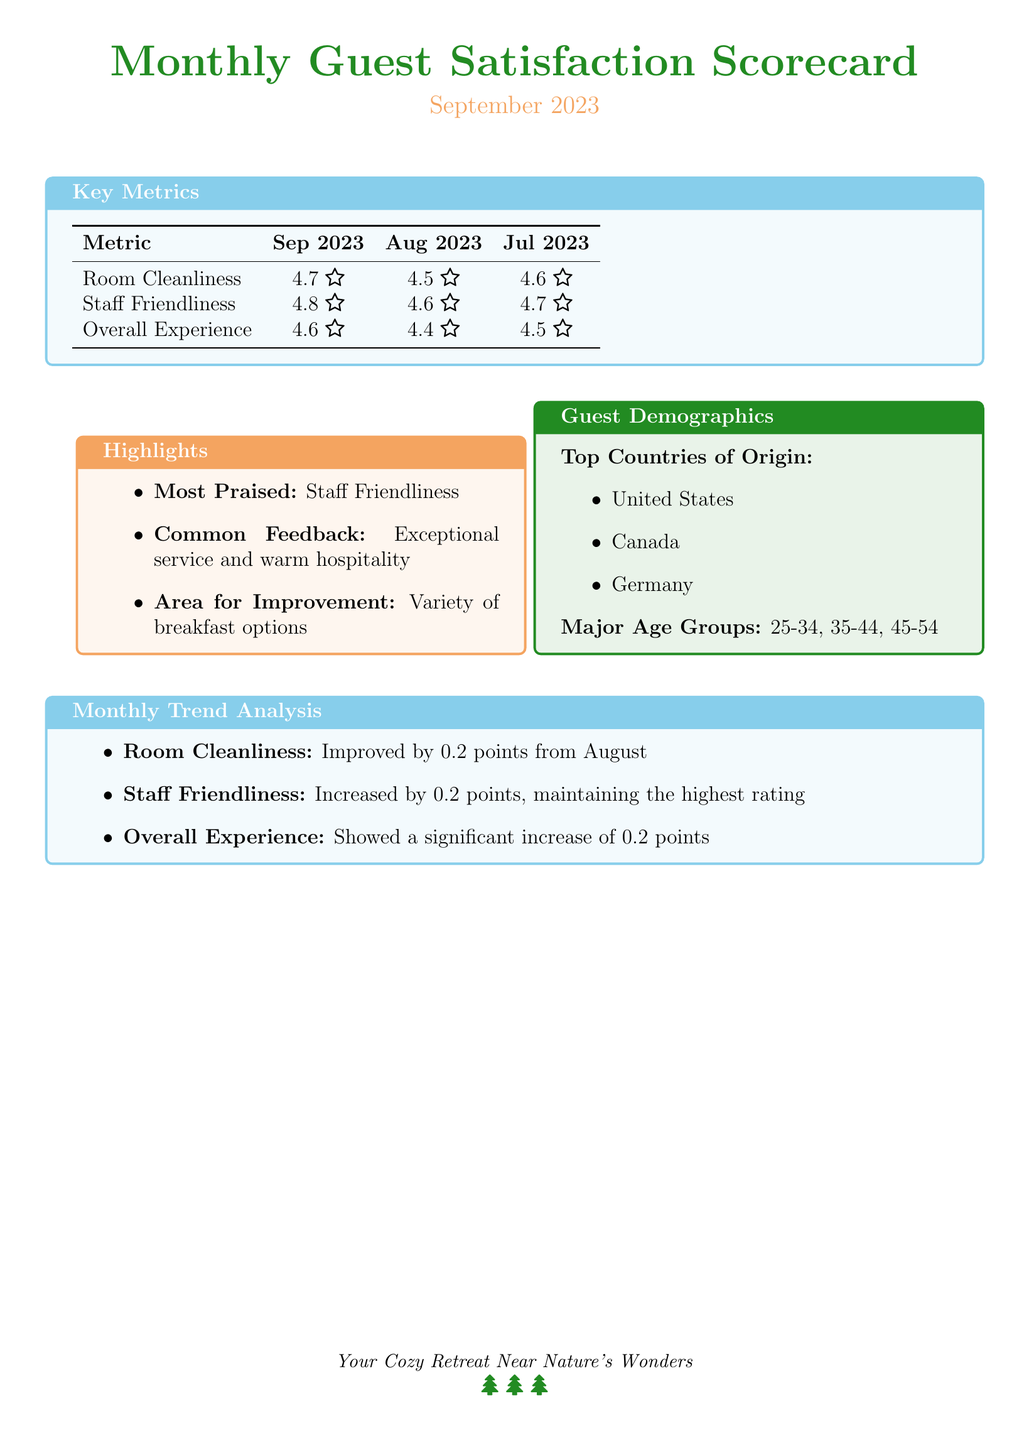What was the average guest rating for room cleanliness in September 2023? The average guest rating for room cleanliness in September 2023 is found in the Key Metrics section of the document.
Answer: 4.7 Which metric improved by 0.2 points from August to September? The Monthly Trend Analysis section indicates specific metrics that improved from August to September.
Answer: Room Cleanliness What was the average guest rating for staff friendliness in August 2023? The average rating for staff friendliness in August 2023 can be found in the Key Metrics table comparing different months.
Answer: 4.6 What were the top three countries of origin for guests? The Guest Demographics section lists the top countries, which can be extracted directly.
Answer: United States, Canada, Germany What common feedback did guests provide for September 2023? The Highlights section summarizes feedback provided by guests, detailing their experiences.
Answer: Exceptional service and warm hospitality What was the overall experience rating for September 2023? The overall experience rating is located in the Key Metrics table for September 2023.
Answer: 4.6 Which area was identified for improvement in September 2023? Area for improvement is specified in the Highlights section, reflecting guest feedback.
Answer: Variety of breakfast options What age group was not mentioned among the major demographics? The demographics section lists specific major age groups, implying others are not included.
Answer: 18-24 How much did the overall experience rating increase from July to September? The document indicates the overall experience ratings for both months, allowing for a comparison of changes.
Answer: 0.1 